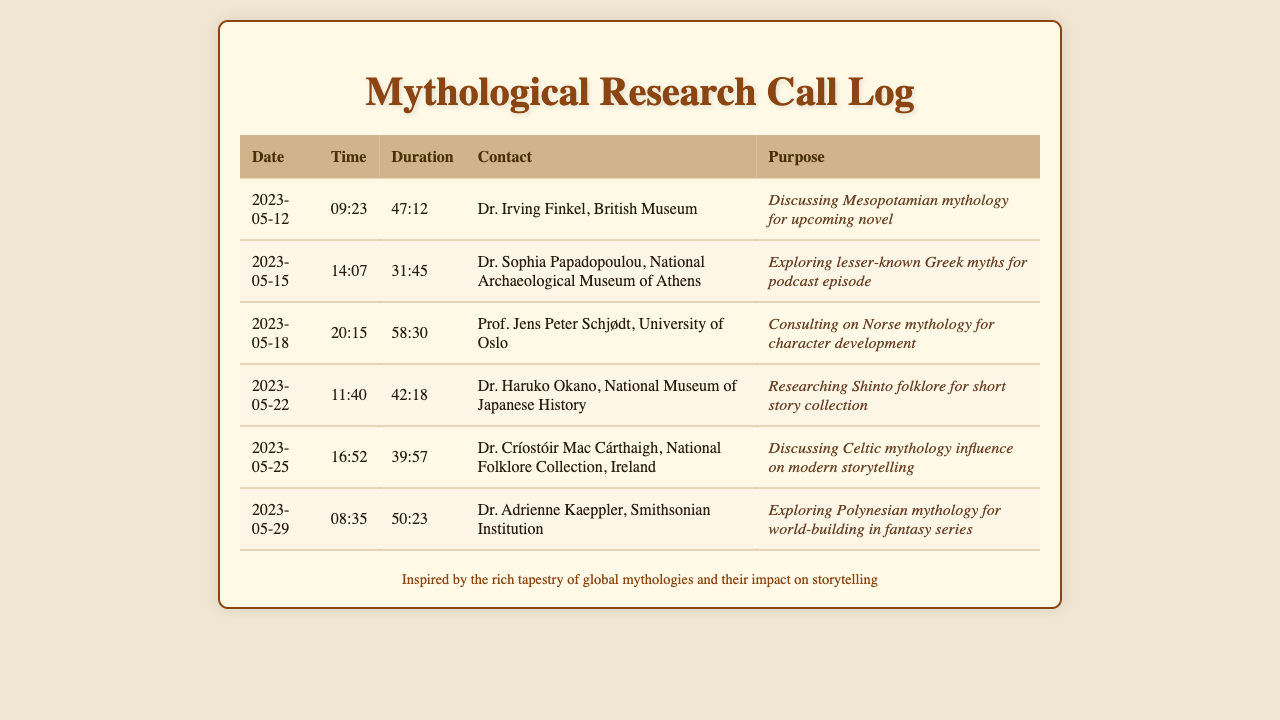what date did the call to Dr. Irving Finkel take place? The call to Dr. Irving Finkel occurred on May 12, 2023.
Answer: May 12, 2023 how long was the call with Dr. Sophia Papadopoulou? The call with Dr. Sophia Papadopoulou lasted 31 minutes and 45 seconds.
Answer: 31:45 who was consulted for character development? Prof. Jens Peter Schjødt was consulted for character development regarding Norse mythology.
Answer: Prof. Jens Peter Schjødt what was the purpose of the call with Dr. Haruko Okano? The purpose was to research Shinto folklore for a short story collection.
Answer: Researching Shinto folklore which expert is associated with the Smithsonian Institution? Dr. Adrienne Kaeppler is associated with the Smithsonian Institution.
Answer: Dr. Adrienne Kaeppler how many calls were made to mythologists listed in the document? There were six calls made to mythologists listed in the document.
Answer: 6 